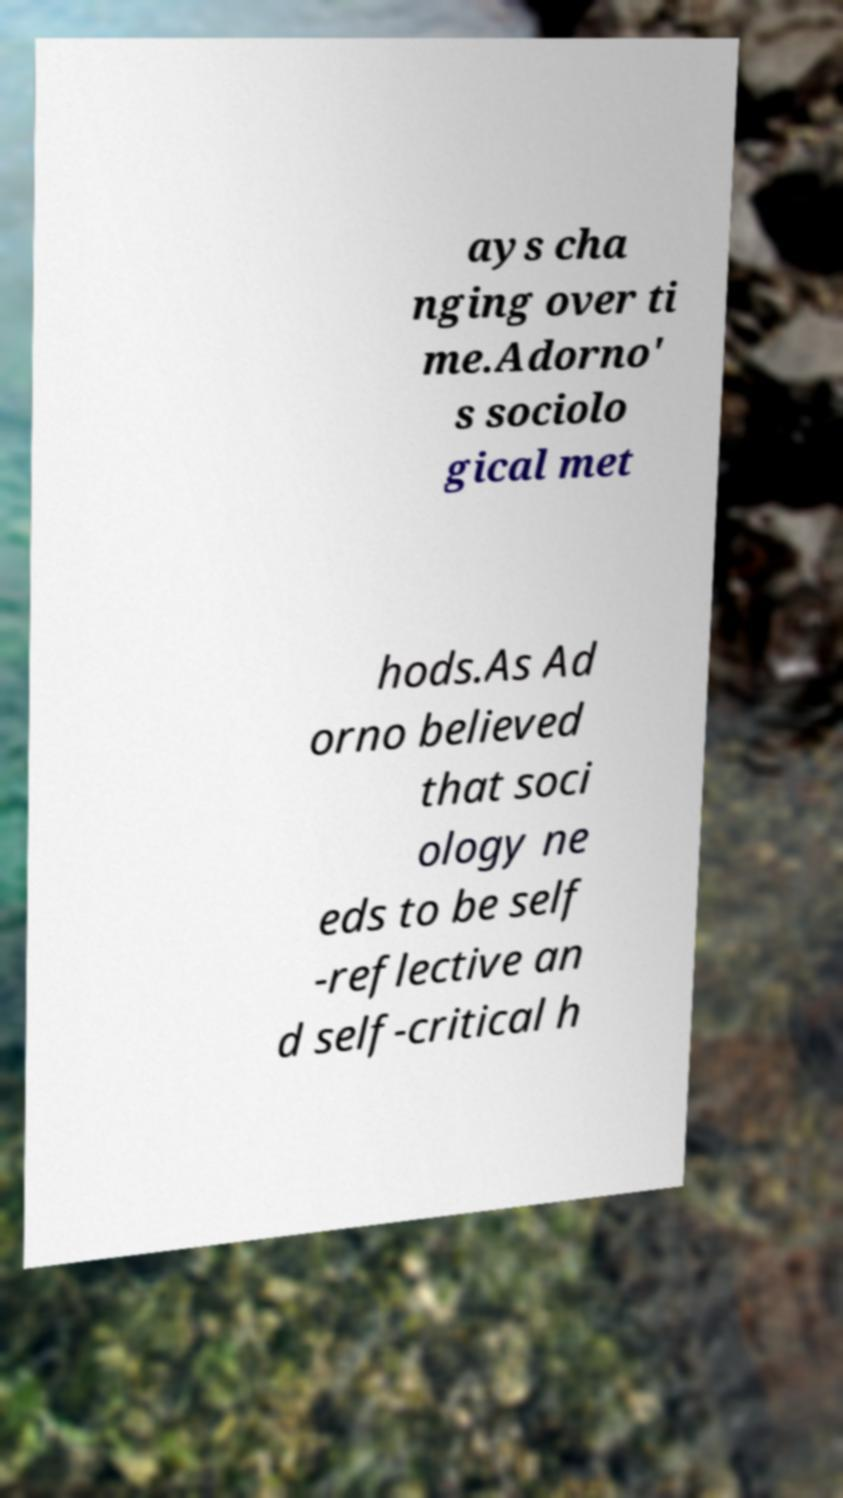For documentation purposes, I need the text within this image transcribed. Could you provide that? ays cha nging over ti me.Adorno' s sociolo gical met hods.As Ad orno believed that soci ology ne eds to be self -reflective an d self-critical h 